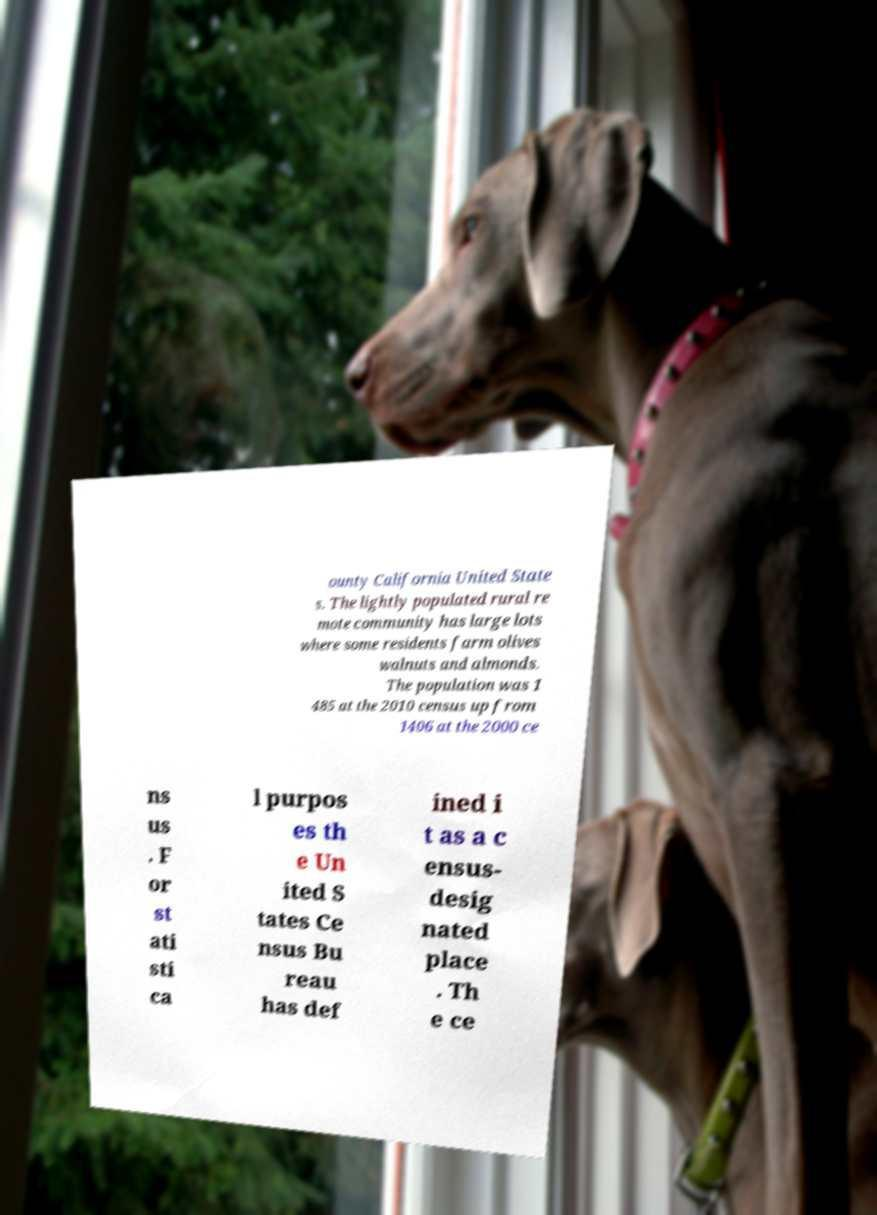Please identify and transcribe the text found in this image. ounty California United State s. The lightly populated rural re mote community has large lots where some residents farm olives walnuts and almonds. The population was 1 485 at the 2010 census up from 1406 at the 2000 ce ns us . F or st ati sti ca l purpos es th e Un ited S tates Ce nsus Bu reau has def ined i t as a c ensus- desig nated place . Th e ce 